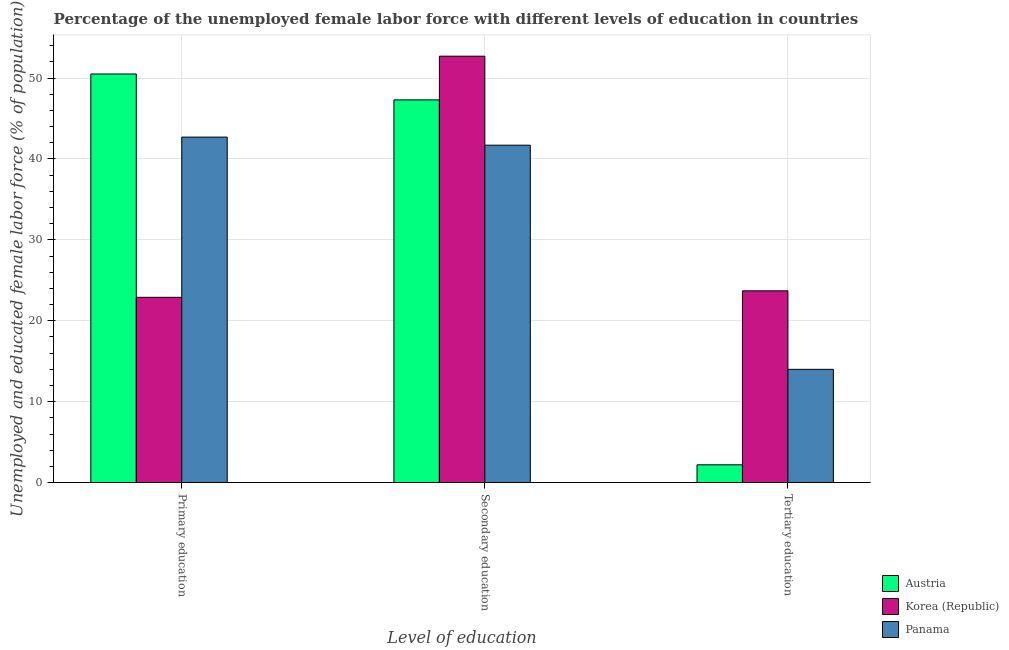How many groups of bars are there?
Your answer should be compact. 3. Are the number of bars per tick equal to the number of legend labels?
Make the answer very short. Yes. Are the number of bars on each tick of the X-axis equal?
Your answer should be very brief. Yes. What is the label of the 1st group of bars from the left?
Keep it short and to the point. Primary education. What is the percentage of female labor force who received tertiary education in Austria?
Give a very brief answer. 2.2. Across all countries, what is the maximum percentage of female labor force who received tertiary education?
Ensure brevity in your answer.  23.7. Across all countries, what is the minimum percentage of female labor force who received secondary education?
Offer a very short reply. 41.7. In which country was the percentage of female labor force who received primary education minimum?
Give a very brief answer. Korea (Republic). What is the total percentage of female labor force who received tertiary education in the graph?
Offer a very short reply. 39.9. What is the difference between the percentage of female labor force who received secondary education in Korea (Republic) and that in Austria?
Offer a terse response. 5.4. What is the difference between the percentage of female labor force who received secondary education in Austria and the percentage of female labor force who received tertiary education in Panama?
Give a very brief answer. 33.3. What is the average percentage of female labor force who received tertiary education per country?
Your answer should be compact. 13.3. What is the difference between the percentage of female labor force who received primary education and percentage of female labor force who received secondary education in Korea (Republic)?
Give a very brief answer. -29.8. In how many countries, is the percentage of female labor force who received tertiary education greater than 24 %?
Give a very brief answer. 0. What is the ratio of the percentage of female labor force who received secondary education in Korea (Republic) to that in Panama?
Your answer should be very brief. 1.26. Is the percentage of female labor force who received primary education in Korea (Republic) less than that in Panama?
Your answer should be very brief. Yes. Is the difference between the percentage of female labor force who received secondary education in Panama and Korea (Republic) greater than the difference between the percentage of female labor force who received primary education in Panama and Korea (Republic)?
Give a very brief answer. No. What is the difference between the highest and the second highest percentage of female labor force who received primary education?
Offer a terse response. 7.8. What is the difference between the highest and the lowest percentage of female labor force who received tertiary education?
Ensure brevity in your answer.  21.5. Is the sum of the percentage of female labor force who received primary education in Korea (Republic) and Panama greater than the maximum percentage of female labor force who received tertiary education across all countries?
Make the answer very short. Yes. What does the 2nd bar from the right in Secondary education represents?
Ensure brevity in your answer.  Korea (Republic). Are all the bars in the graph horizontal?
Offer a terse response. No. What is the difference between two consecutive major ticks on the Y-axis?
Make the answer very short. 10. Are the values on the major ticks of Y-axis written in scientific E-notation?
Offer a terse response. No. Does the graph contain any zero values?
Your answer should be very brief. No. Does the graph contain grids?
Your answer should be very brief. Yes. How are the legend labels stacked?
Your answer should be very brief. Vertical. What is the title of the graph?
Offer a terse response. Percentage of the unemployed female labor force with different levels of education in countries. Does "Singapore" appear as one of the legend labels in the graph?
Make the answer very short. No. What is the label or title of the X-axis?
Your answer should be compact. Level of education. What is the label or title of the Y-axis?
Provide a short and direct response. Unemployed and educated female labor force (% of population). What is the Unemployed and educated female labor force (% of population) in Austria in Primary education?
Make the answer very short. 50.5. What is the Unemployed and educated female labor force (% of population) in Korea (Republic) in Primary education?
Offer a very short reply. 22.9. What is the Unemployed and educated female labor force (% of population) in Panama in Primary education?
Your response must be concise. 42.7. What is the Unemployed and educated female labor force (% of population) of Austria in Secondary education?
Provide a succinct answer. 47.3. What is the Unemployed and educated female labor force (% of population) in Korea (Republic) in Secondary education?
Provide a short and direct response. 52.7. What is the Unemployed and educated female labor force (% of population) of Panama in Secondary education?
Make the answer very short. 41.7. What is the Unemployed and educated female labor force (% of population) of Austria in Tertiary education?
Your response must be concise. 2.2. What is the Unemployed and educated female labor force (% of population) of Korea (Republic) in Tertiary education?
Keep it short and to the point. 23.7. What is the Unemployed and educated female labor force (% of population) in Panama in Tertiary education?
Provide a short and direct response. 14. Across all Level of education, what is the maximum Unemployed and educated female labor force (% of population) in Austria?
Offer a terse response. 50.5. Across all Level of education, what is the maximum Unemployed and educated female labor force (% of population) in Korea (Republic)?
Your response must be concise. 52.7. Across all Level of education, what is the maximum Unemployed and educated female labor force (% of population) of Panama?
Give a very brief answer. 42.7. Across all Level of education, what is the minimum Unemployed and educated female labor force (% of population) of Austria?
Offer a terse response. 2.2. Across all Level of education, what is the minimum Unemployed and educated female labor force (% of population) of Korea (Republic)?
Keep it short and to the point. 22.9. Across all Level of education, what is the minimum Unemployed and educated female labor force (% of population) in Panama?
Keep it short and to the point. 14. What is the total Unemployed and educated female labor force (% of population) of Korea (Republic) in the graph?
Offer a terse response. 99.3. What is the total Unemployed and educated female labor force (% of population) of Panama in the graph?
Your answer should be very brief. 98.4. What is the difference between the Unemployed and educated female labor force (% of population) in Korea (Republic) in Primary education and that in Secondary education?
Make the answer very short. -29.8. What is the difference between the Unemployed and educated female labor force (% of population) of Austria in Primary education and that in Tertiary education?
Offer a terse response. 48.3. What is the difference between the Unemployed and educated female labor force (% of population) in Korea (Republic) in Primary education and that in Tertiary education?
Ensure brevity in your answer.  -0.8. What is the difference between the Unemployed and educated female labor force (% of population) in Panama in Primary education and that in Tertiary education?
Ensure brevity in your answer.  28.7. What is the difference between the Unemployed and educated female labor force (% of population) in Austria in Secondary education and that in Tertiary education?
Offer a terse response. 45.1. What is the difference between the Unemployed and educated female labor force (% of population) in Panama in Secondary education and that in Tertiary education?
Ensure brevity in your answer.  27.7. What is the difference between the Unemployed and educated female labor force (% of population) in Austria in Primary education and the Unemployed and educated female labor force (% of population) in Korea (Republic) in Secondary education?
Provide a short and direct response. -2.2. What is the difference between the Unemployed and educated female labor force (% of population) of Korea (Republic) in Primary education and the Unemployed and educated female labor force (% of population) of Panama in Secondary education?
Offer a very short reply. -18.8. What is the difference between the Unemployed and educated female labor force (% of population) in Austria in Primary education and the Unemployed and educated female labor force (% of population) in Korea (Republic) in Tertiary education?
Offer a very short reply. 26.8. What is the difference between the Unemployed and educated female labor force (% of population) in Austria in Primary education and the Unemployed and educated female labor force (% of population) in Panama in Tertiary education?
Offer a terse response. 36.5. What is the difference between the Unemployed and educated female labor force (% of population) of Austria in Secondary education and the Unemployed and educated female labor force (% of population) of Korea (Republic) in Tertiary education?
Your response must be concise. 23.6. What is the difference between the Unemployed and educated female labor force (% of population) in Austria in Secondary education and the Unemployed and educated female labor force (% of population) in Panama in Tertiary education?
Provide a succinct answer. 33.3. What is the difference between the Unemployed and educated female labor force (% of population) of Korea (Republic) in Secondary education and the Unemployed and educated female labor force (% of population) of Panama in Tertiary education?
Your answer should be compact. 38.7. What is the average Unemployed and educated female labor force (% of population) of Austria per Level of education?
Offer a terse response. 33.33. What is the average Unemployed and educated female labor force (% of population) of Korea (Republic) per Level of education?
Your response must be concise. 33.1. What is the average Unemployed and educated female labor force (% of population) of Panama per Level of education?
Offer a terse response. 32.8. What is the difference between the Unemployed and educated female labor force (% of population) of Austria and Unemployed and educated female labor force (% of population) of Korea (Republic) in Primary education?
Provide a short and direct response. 27.6. What is the difference between the Unemployed and educated female labor force (% of population) of Korea (Republic) and Unemployed and educated female labor force (% of population) of Panama in Primary education?
Provide a short and direct response. -19.8. What is the difference between the Unemployed and educated female labor force (% of population) of Austria and Unemployed and educated female labor force (% of population) of Korea (Republic) in Secondary education?
Keep it short and to the point. -5.4. What is the difference between the Unemployed and educated female labor force (% of population) in Austria and Unemployed and educated female labor force (% of population) in Korea (Republic) in Tertiary education?
Your answer should be very brief. -21.5. What is the difference between the Unemployed and educated female labor force (% of population) in Korea (Republic) and Unemployed and educated female labor force (% of population) in Panama in Tertiary education?
Give a very brief answer. 9.7. What is the ratio of the Unemployed and educated female labor force (% of population) in Austria in Primary education to that in Secondary education?
Your answer should be very brief. 1.07. What is the ratio of the Unemployed and educated female labor force (% of population) of Korea (Republic) in Primary education to that in Secondary education?
Offer a very short reply. 0.43. What is the ratio of the Unemployed and educated female labor force (% of population) of Panama in Primary education to that in Secondary education?
Ensure brevity in your answer.  1.02. What is the ratio of the Unemployed and educated female labor force (% of population) of Austria in Primary education to that in Tertiary education?
Your answer should be compact. 22.95. What is the ratio of the Unemployed and educated female labor force (% of population) in Korea (Republic) in Primary education to that in Tertiary education?
Your answer should be very brief. 0.97. What is the ratio of the Unemployed and educated female labor force (% of population) of Panama in Primary education to that in Tertiary education?
Your response must be concise. 3.05. What is the ratio of the Unemployed and educated female labor force (% of population) of Korea (Republic) in Secondary education to that in Tertiary education?
Offer a very short reply. 2.22. What is the ratio of the Unemployed and educated female labor force (% of population) in Panama in Secondary education to that in Tertiary education?
Provide a short and direct response. 2.98. What is the difference between the highest and the second highest Unemployed and educated female labor force (% of population) in Korea (Republic)?
Provide a succinct answer. 29. What is the difference between the highest and the second highest Unemployed and educated female labor force (% of population) in Panama?
Provide a short and direct response. 1. What is the difference between the highest and the lowest Unemployed and educated female labor force (% of population) in Austria?
Your answer should be very brief. 48.3. What is the difference between the highest and the lowest Unemployed and educated female labor force (% of population) in Korea (Republic)?
Provide a short and direct response. 29.8. What is the difference between the highest and the lowest Unemployed and educated female labor force (% of population) of Panama?
Offer a very short reply. 28.7. 